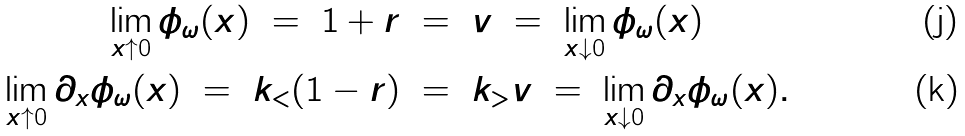<formula> <loc_0><loc_0><loc_500><loc_500>\lim _ { x \uparrow 0 } \phi _ { \omega } ( x ) \ = \ 1 + r \ & = \ v \ = \ \lim _ { x \downarrow 0 } \phi _ { \omega } ( x ) \\ \lim _ { x \uparrow 0 } \partial _ { x } \phi _ { \omega } ( x ) \ = \ k _ { < } ( 1 - r ) \ & = \ k _ { > } v \ = \ \lim _ { x \downarrow 0 } \partial _ { x } \phi _ { \omega } ( x ) .</formula> 